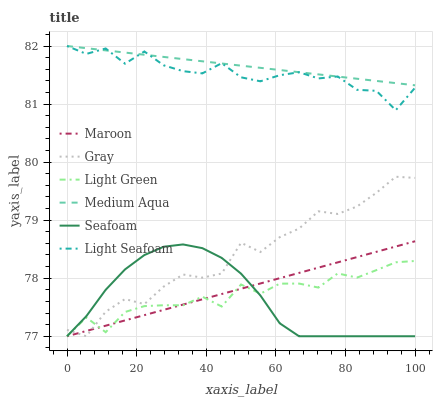Does Seafoam have the minimum area under the curve?
Answer yes or no. Yes. Does Medium Aqua have the maximum area under the curve?
Answer yes or no. Yes. Does Maroon have the minimum area under the curve?
Answer yes or no. No. Does Maroon have the maximum area under the curve?
Answer yes or no. No. Is Medium Aqua the smoothest?
Answer yes or no. Yes. Is Gray the roughest?
Answer yes or no. Yes. Is Seafoam the smoothest?
Answer yes or no. No. Is Seafoam the roughest?
Answer yes or no. No. Does Gray have the lowest value?
Answer yes or no. Yes. Does Medium Aqua have the lowest value?
Answer yes or no. No. Does Light Seafoam have the highest value?
Answer yes or no. Yes. Does Seafoam have the highest value?
Answer yes or no. No. Is Maroon less than Light Seafoam?
Answer yes or no. Yes. Is Light Seafoam greater than Seafoam?
Answer yes or no. Yes. Does Maroon intersect Gray?
Answer yes or no. Yes. Is Maroon less than Gray?
Answer yes or no. No. Is Maroon greater than Gray?
Answer yes or no. No. Does Maroon intersect Light Seafoam?
Answer yes or no. No. 